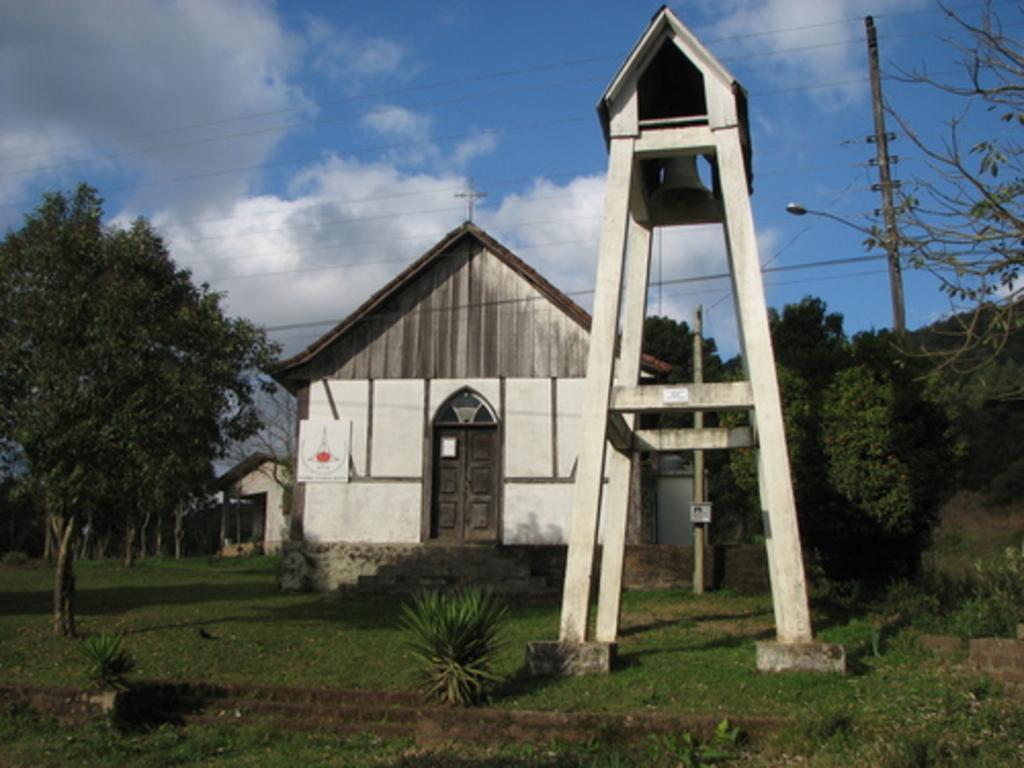In one or two sentences, can you explain what this image depicts? In this picture there are few plants and grassland at the bottom side of the image, there is a wooden structure on the right side, it seems like a church in the center. There are trees, shed, wires, pole and sky in the background area. 